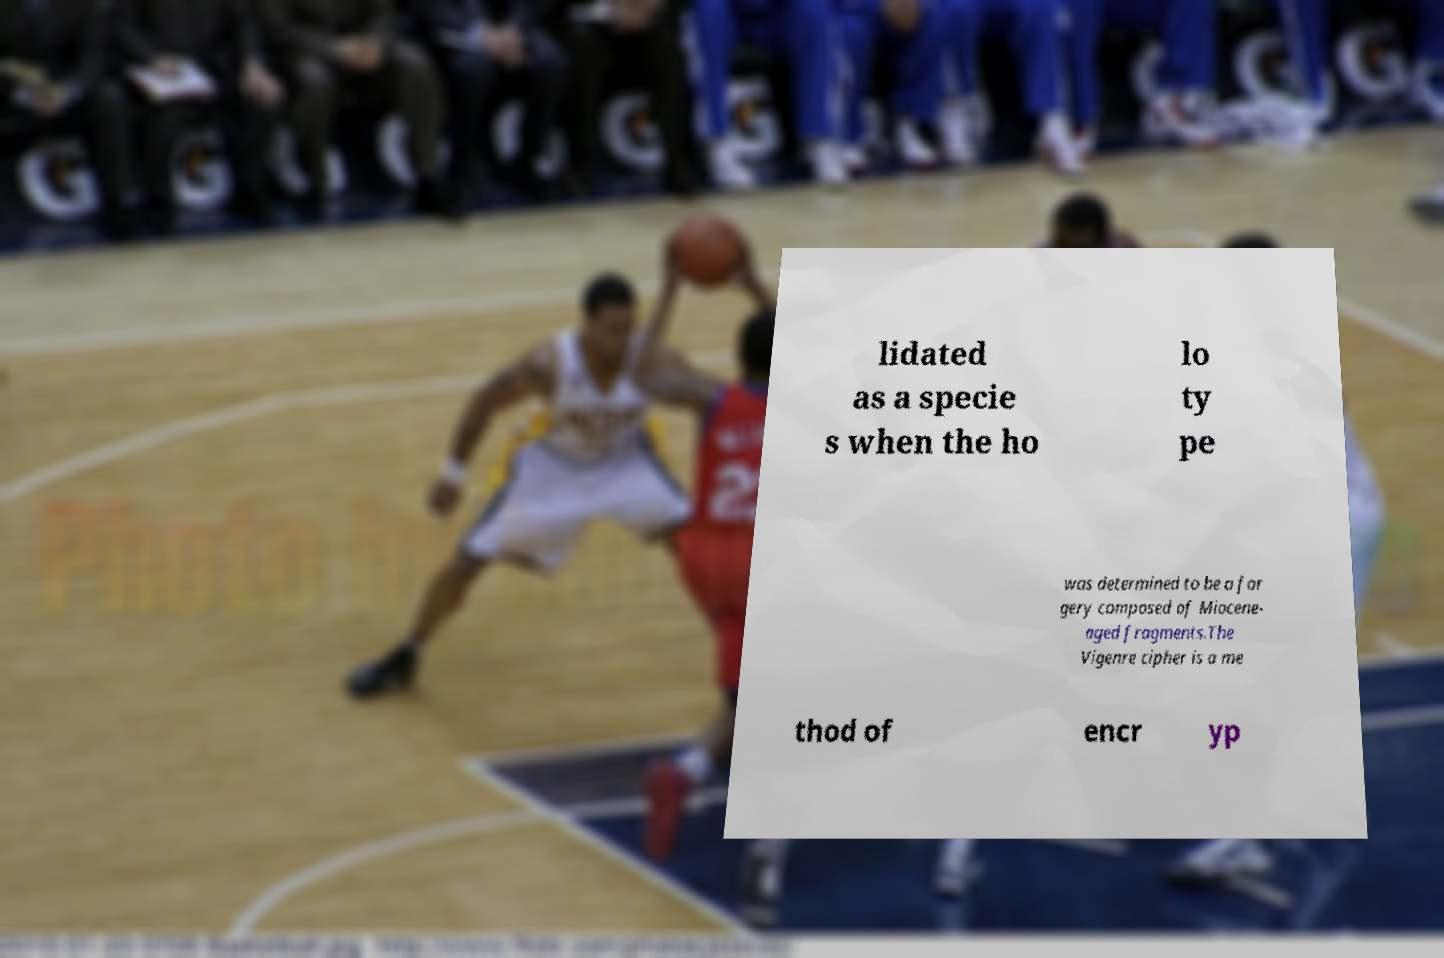Please identify and transcribe the text found in this image. lidated as a specie s when the ho lo ty pe was determined to be a for gery composed of Miocene- aged fragments.The Vigenre cipher is a me thod of encr yp 